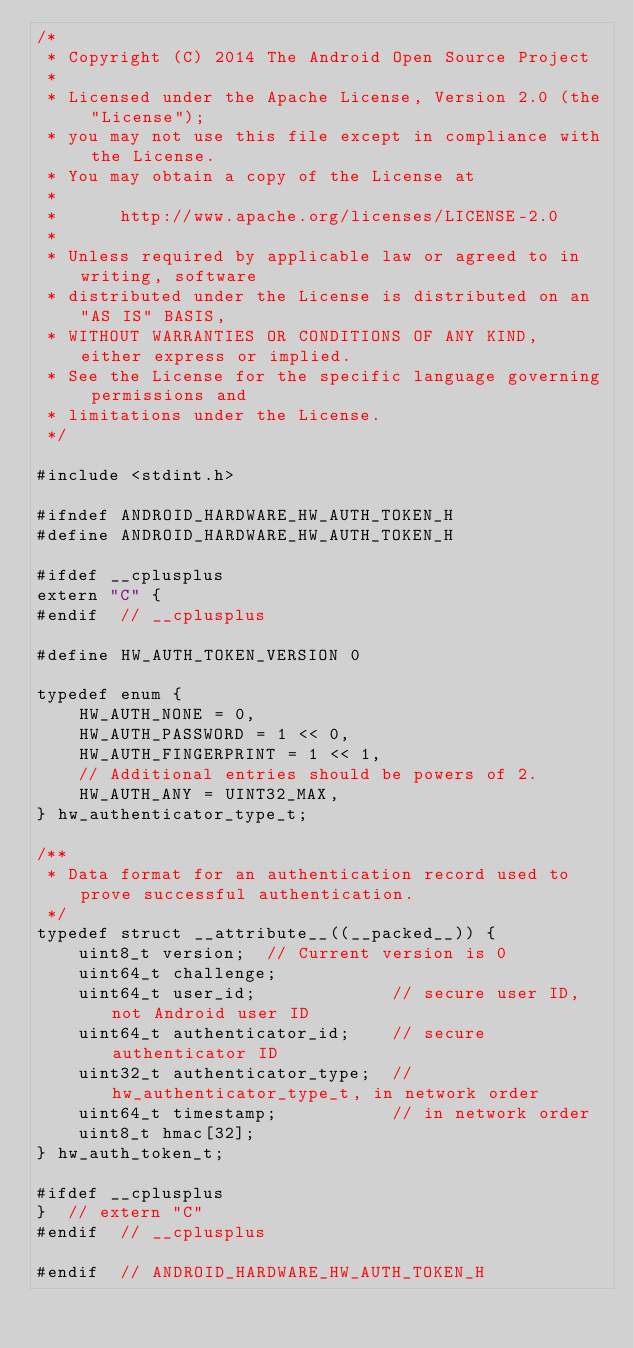<code> <loc_0><loc_0><loc_500><loc_500><_C_>/*
 * Copyright (C) 2014 The Android Open Source Project
 *
 * Licensed under the Apache License, Version 2.0 (the "License");
 * you may not use this file except in compliance with the License.
 * You may obtain a copy of the License at
 *
 *      http://www.apache.org/licenses/LICENSE-2.0
 *
 * Unless required by applicable law or agreed to in writing, software
 * distributed under the License is distributed on an "AS IS" BASIS,
 * WITHOUT WARRANTIES OR CONDITIONS OF ANY KIND, either express or implied.
 * See the License for the specific language governing permissions and
 * limitations under the License.
 */

#include <stdint.h>

#ifndef ANDROID_HARDWARE_HW_AUTH_TOKEN_H
#define ANDROID_HARDWARE_HW_AUTH_TOKEN_H

#ifdef __cplusplus
extern "C" {
#endif  // __cplusplus

#define HW_AUTH_TOKEN_VERSION 0

typedef enum {
    HW_AUTH_NONE = 0,
    HW_AUTH_PASSWORD = 1 << 0,
    HW_AUTH_FINGERPRINT = 1 << 1,
    // Additional entries should be powers of 2.
    HW_AUTH_ANY = UINT32_MAX,
} hw_authenticator_type_t;

/**
 * Data format for an authentication record used to prove successful authentication.
 */
typedef struct __attribute__((__packed__)) {
    uint8_t version;  // Current version is 0
    uint64_t challenge;
    uint64_t user_id;             // secure user ID, not Android user ID
    uint64_t authenticator_id;    // secure authenticator ID
    uint32_t authenticator_type;  // hw_authenticator_type_t, in network order
    uint64_t timestamp;           // in network order
    uint8_t hmac[32];
} hw_auth_token_t;

#ifdef __cplusplus
}  // extern "C"
#endif  // __cplusplus

#endif  // ANDROID_HARDWARE_HW_AUTH_TOKEN_H
</code> 